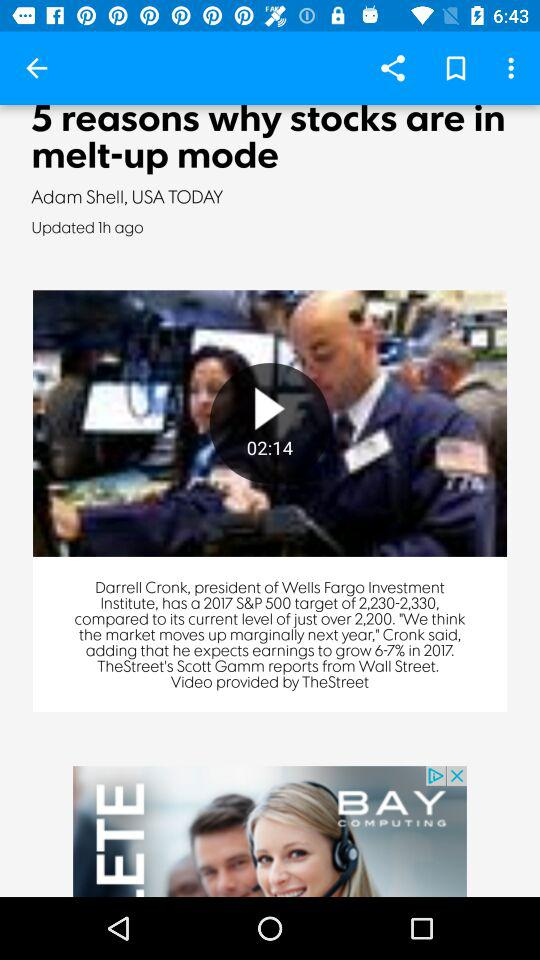How many hours ago was the news updated? The news was updated 1 hour ago. 